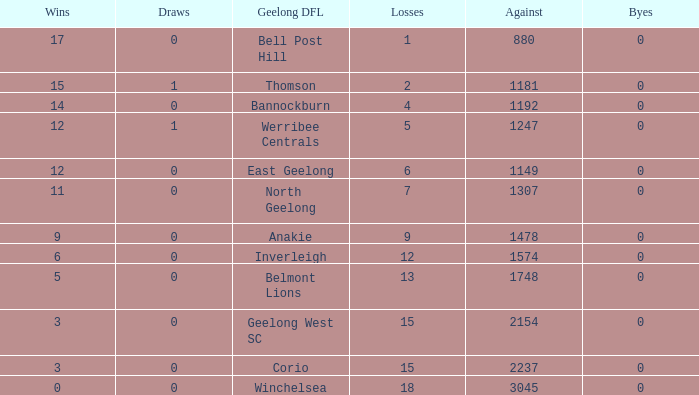What is the highest number of byes where the losses were 9 and the draws were less than 0? None. 